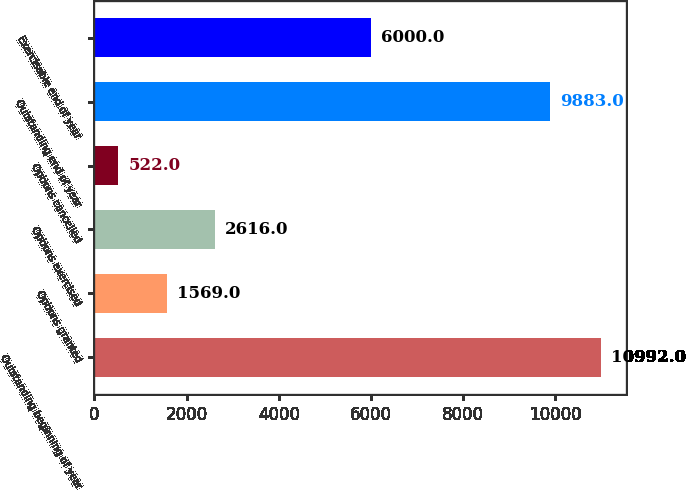<chart> <loc_0><loc_0><loc_500><loc_500><bar_chart><fcel>Outstanding beginning of year<fcel>Options granted<fcel>Options exercised<fcel>Options cancelled<fcel>Outstanding end of year<fcel>Exercisable end of year<nl><fcel>10992<fcel>1569<fcel>2616<fcel>522<fcel>9883<fcel>6000<nl></chart> 